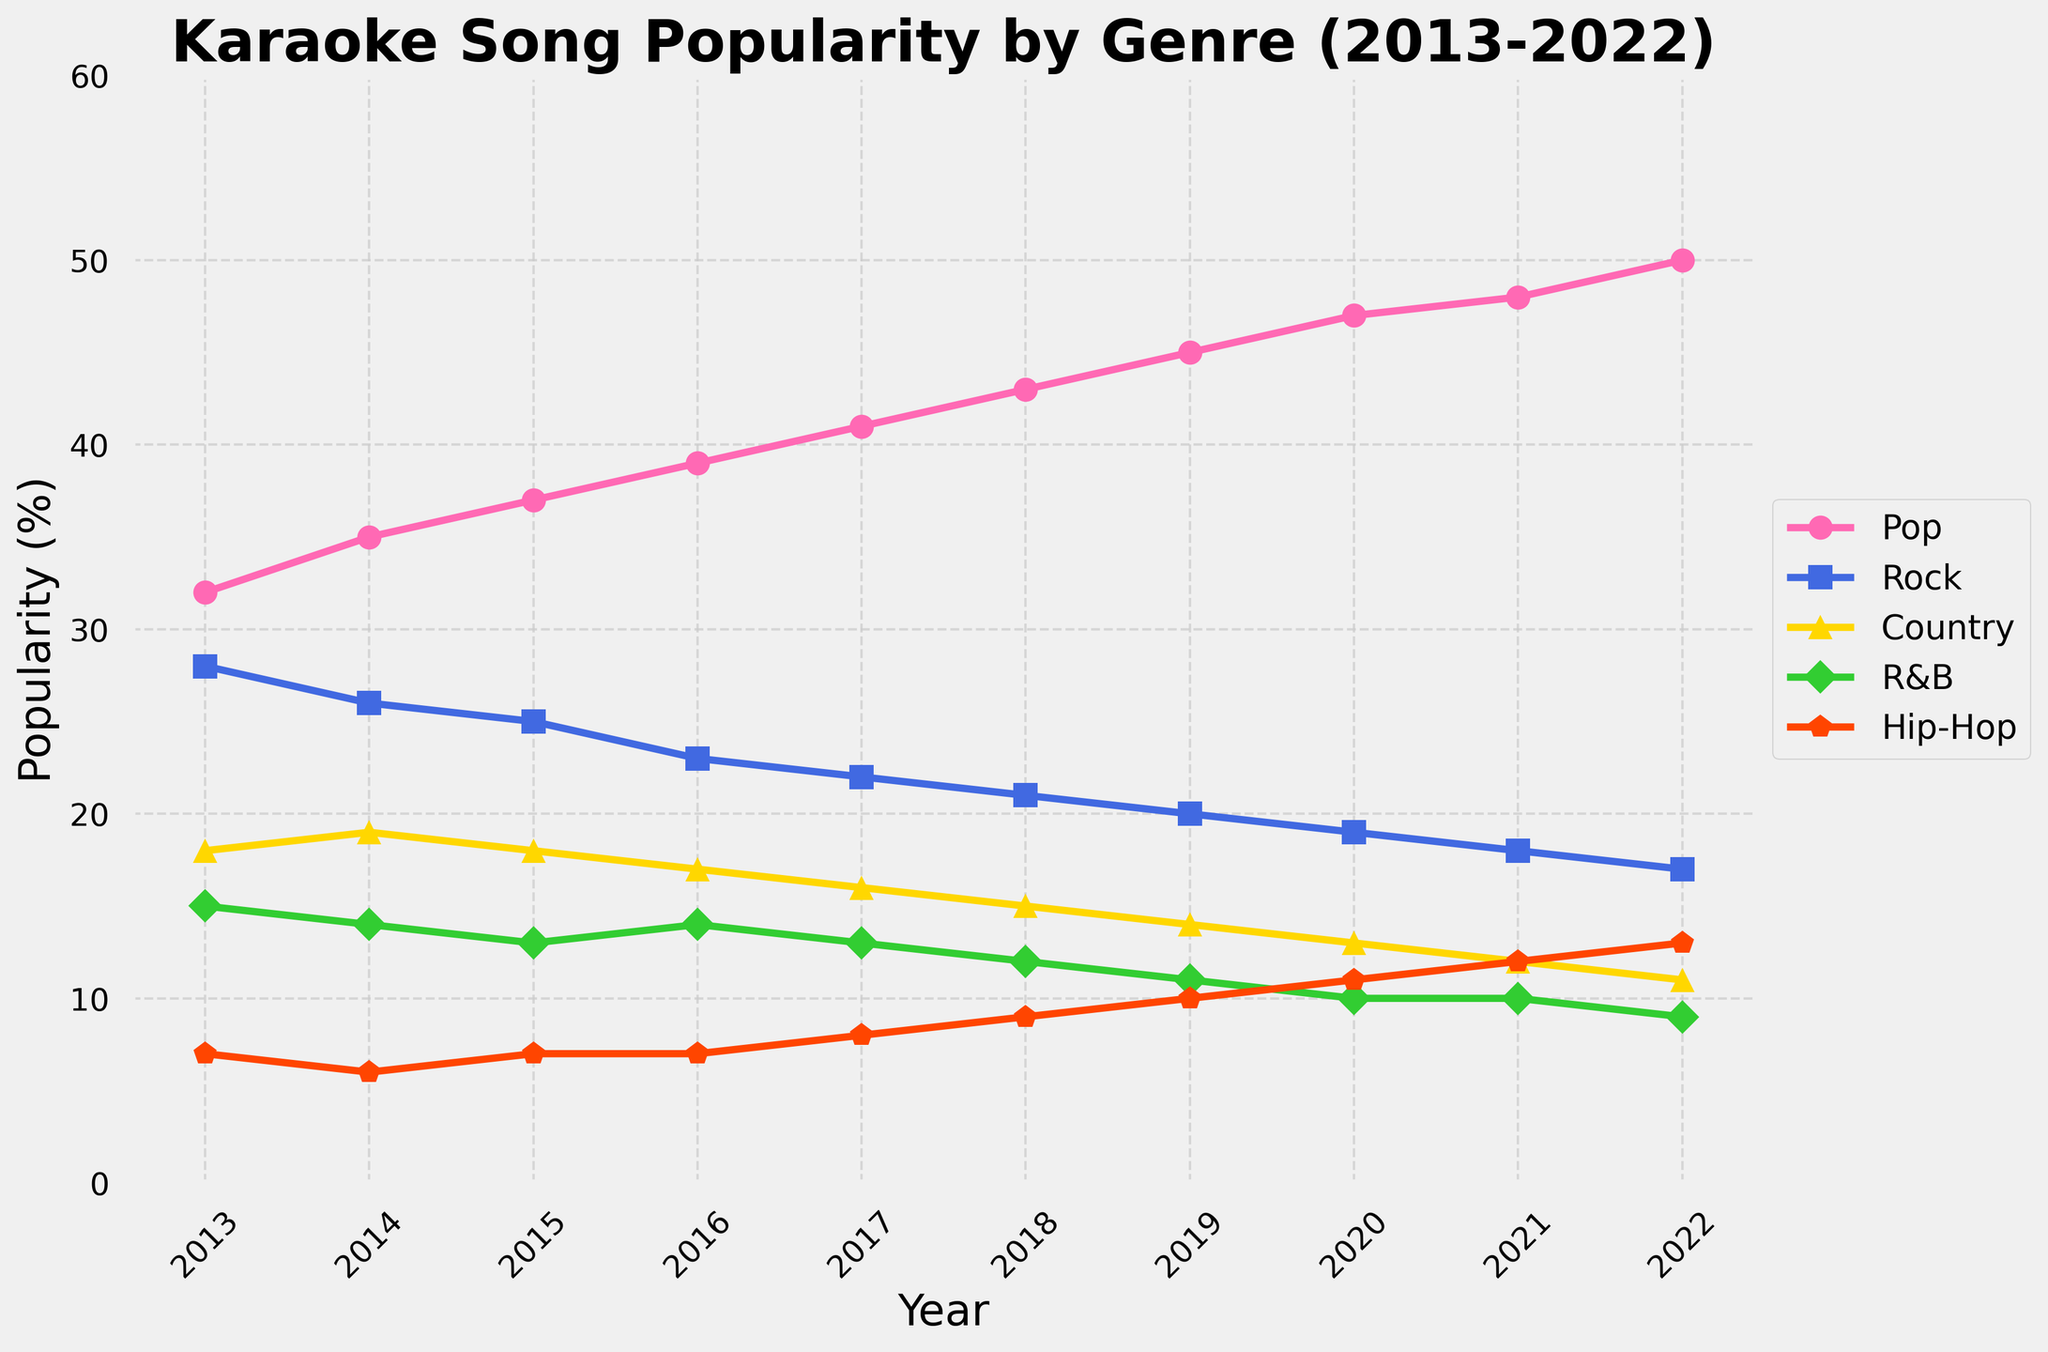What's the most popular genre in 2018? To answer this, look at the figure for the year 2018. Compare the heights of the lines. The highest line represents the most popular genre that year.
Answer: Pop Which genre shows the most significant increase in popularity from 2013 to 2022? Check the initial and final points for each genre's line on the figure. Calculate the difference between the start and end points for each line. The line with the largest difference represents the genre with the most significant increase.
Answer: Pop Has any genre's popularity remained constant over the decade? Analyze each line's trend across the figure. If a line shows no significant rise or fall, the genre's popularity has remained constant.
Answer: No Compare the popularity of Rock and Hip-Hop in 2019. Which was more popular? Look at the height of the lines representing Rock and Hip-Hop for the year 2019. The higher line indicates the more popular genre.
Answer: Rock What's the overall trend for Country music from 2013 to 2022? Observe the slope and direction of the line representing Country music across the years.
Answer: Downward What is the average popularity of R&B over the decade? Add up the popularity values of R&B for each year (15+14+13+14+13+12+11+10+10+9) and divide by the number of years (10).
Answer: 12.1 In which year did Pop music exceed 45% in popularity? Find the point on the Pop line where it crosses or exceeds the 45% mark.
Answer: 2019 Between 2016 and 2017, which genre experienced a decrease in popularity? Inspect the lines for the years 2016 and 2017. Any genre with a downward slope between these two years experienced a decrease.
Answer: Rock, Country, R&B Which genre had the least popularity in 2020? At the point for the year 2020, identify the shortest line.
Answer: R&B How much did the popularity of Hip-Hop increase from 2013 to 2022? Subtract the popularity of Hip-Hop in 2013 from its value in 2022 (13 - 7 = 6).
Answer: 6 